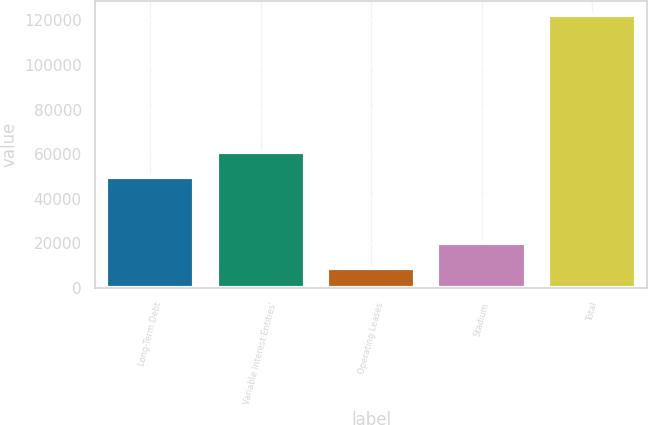Convert chart. <chart><loc_0><loc_0><loc_500><loc_500><bar_chart><fcel>Long-Term Debt<fcel>Variable Interest Entities'<fcel>Operating Leases<fcel>Stadium<fcel>Total<nl><fcel>49605<fcel>60954.2<fcel>8857<fcel>20206.2<fcel>122349<nl></chart> 